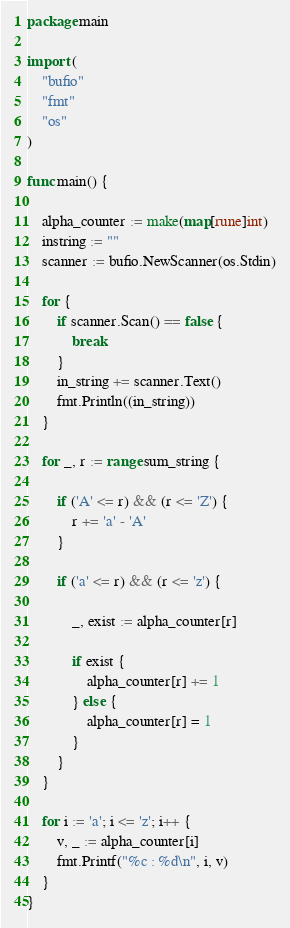<code> <loc_0><loc_0><loc_500><loc_500><_Go_>package main

import (
	"bufio"
	"fmt"
	"os"
)

func main() {

	alpha_counter := make(map[rune]int)
	instring := ""
	scanner := bufio.NewScanner(os.Stdin)

	for {
		if scanner.Scan() == false {
			break
		}
		in_string += scanner.Text()
		fmt.Println((in_string))
	}

	for _, r := range sum_string {

		if ('A' <= r) && (r <= 'Z') {
			r += 'a' - 'A'
		}

		if ('a' <= r) && (r <= 'z') {

			_, exist := alpha_counter[r]

			if exist {
				alpha_counter[r] += 1
			} else {
				alpha_counter[r] = 1
			}
		}
	}

	for i := 'a'; i <= 'z'; i++ {
		v, _ := alpha_counter[i]
		fmt.Printf("%c : %d\n", i, v)
	}
}

</code> 